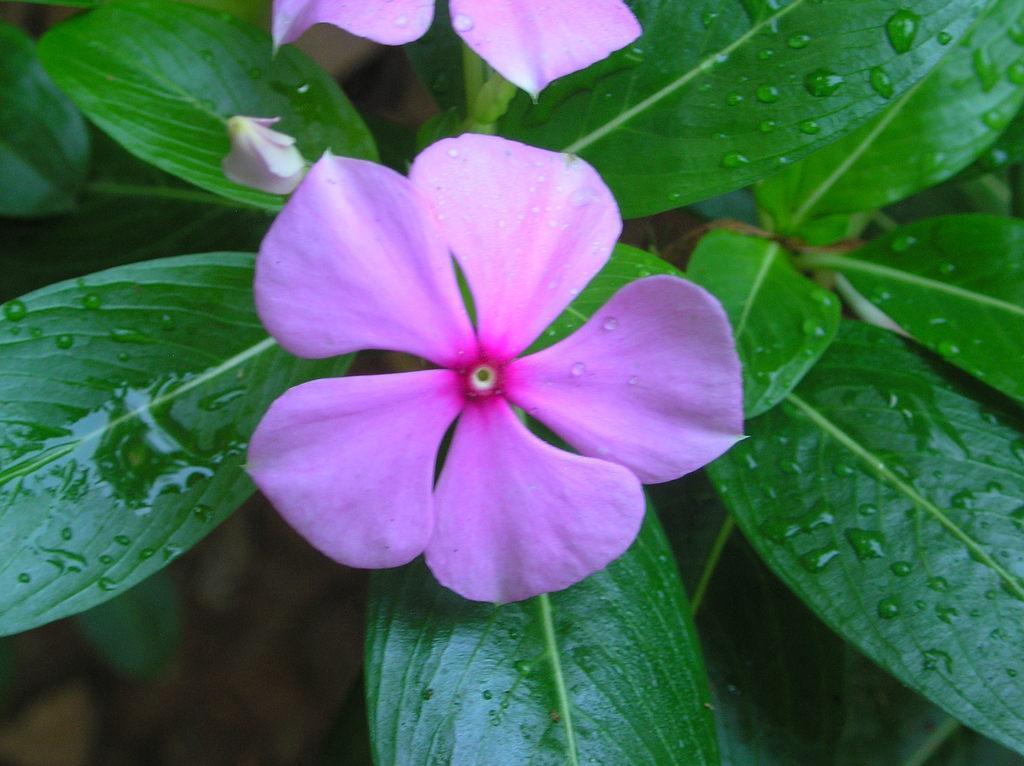Could you give a brief overview of what you see in this image? In this image I can see two pink colour flowers and number of green colour leaves. 